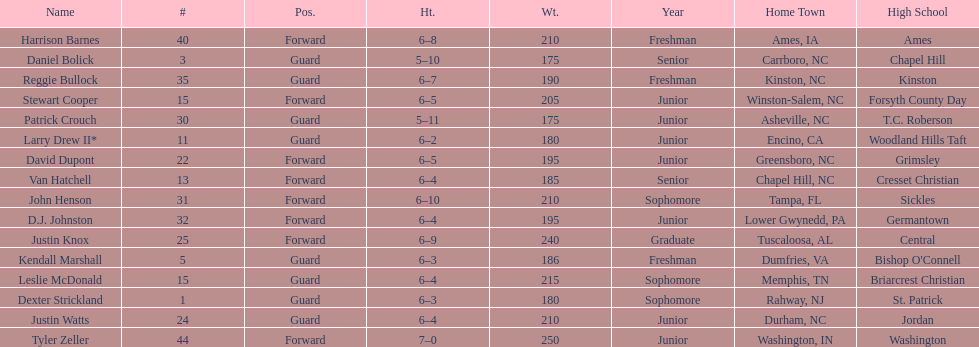Total number of players whose home town was in north carolina (nc) 7. 